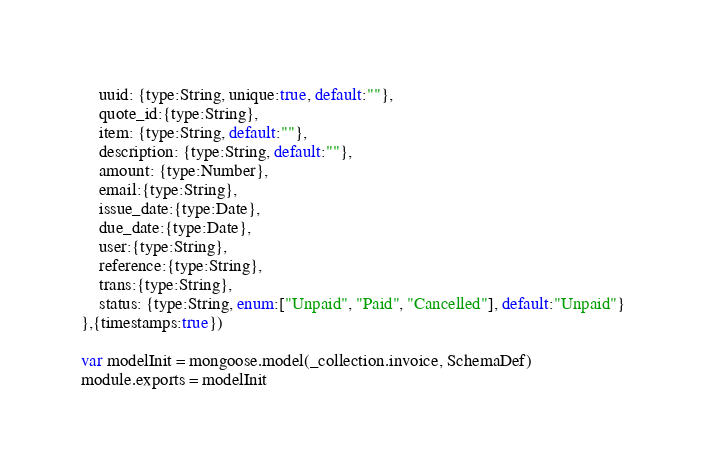<code> <loc_0><loc_0><loc_500><loc_500><_JavaScript_>    uuid: {type:String, unique:true, default:""},
    quote_id:{type:String},
    item: {type:String, default:""},
    description: {type:String, default:""},
    amount: {type:Number},
    email:{type:String},
    issue_date:{type:Date},
    due_date:{type:Date},
    user:{type:String},
    reference:{type:String},
    trans:{type:String},
    status: {type:String, enum:["Unpaid", "Paid", "Cancelled"], default:"Unpaid"}
},{timestamps:true})

var modelInit = mongoose.model(_collection.invoice, SchemaDef)
module.exports = modelInit</code> 